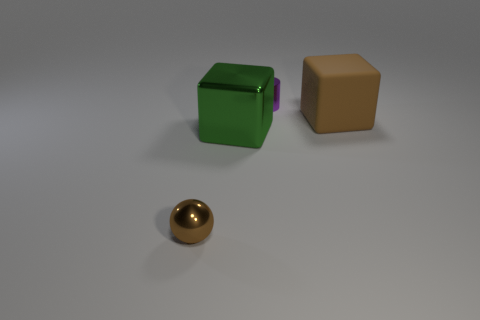Add 3 green objects. How many objects exist? 7 Subtract all balls. How many objects are left? 3 Add 4 small brown things. How many small brown things are left? 5 Add 3 small purple balls. How many small purple balls exist? 3 Subtract 1 purple cylinders. How many objects are left? 3 Subtract all large yellow spheres. Subtract all tiny purple objects. How many objects are left? 3 